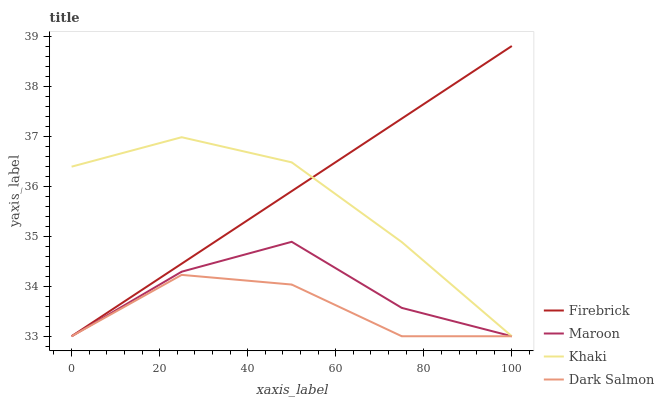Does Dark Salmon have the minimum area under the curve?
Answer yes or no. Yes. Does Firebrick have the maximum area under the curve?
Answer yes or no. Yes. Does Khaki have the minimum area under the curve?
Answer yes or no. No. Does Khaki have the maximum area under the curve?
Answer yes or no. No. Is Firebrick the smoothest?
Answer yes or no. Yes. Is Maroon the roughest?
Answer yes or no. Yes. Is Khaki the smoothest?
Answer yes or no. No. Is Khaki the roughest?
Answer yes or no. No. Does Firebrick have the lowest value?
Answer yes or no. Yes. Does Firebrick have the highest value?
Answer yes or no. Yes. Does Khaki have the highest value?
Answer yes or no. No. Does Dark Salmon intersect Khaki?
Answer yes or no. Yes. Is Dark Salmon less than Khaki?
Answer yes or no. No. Is Dark Salmon greater than Khaki?
Answer yes or no. No. 